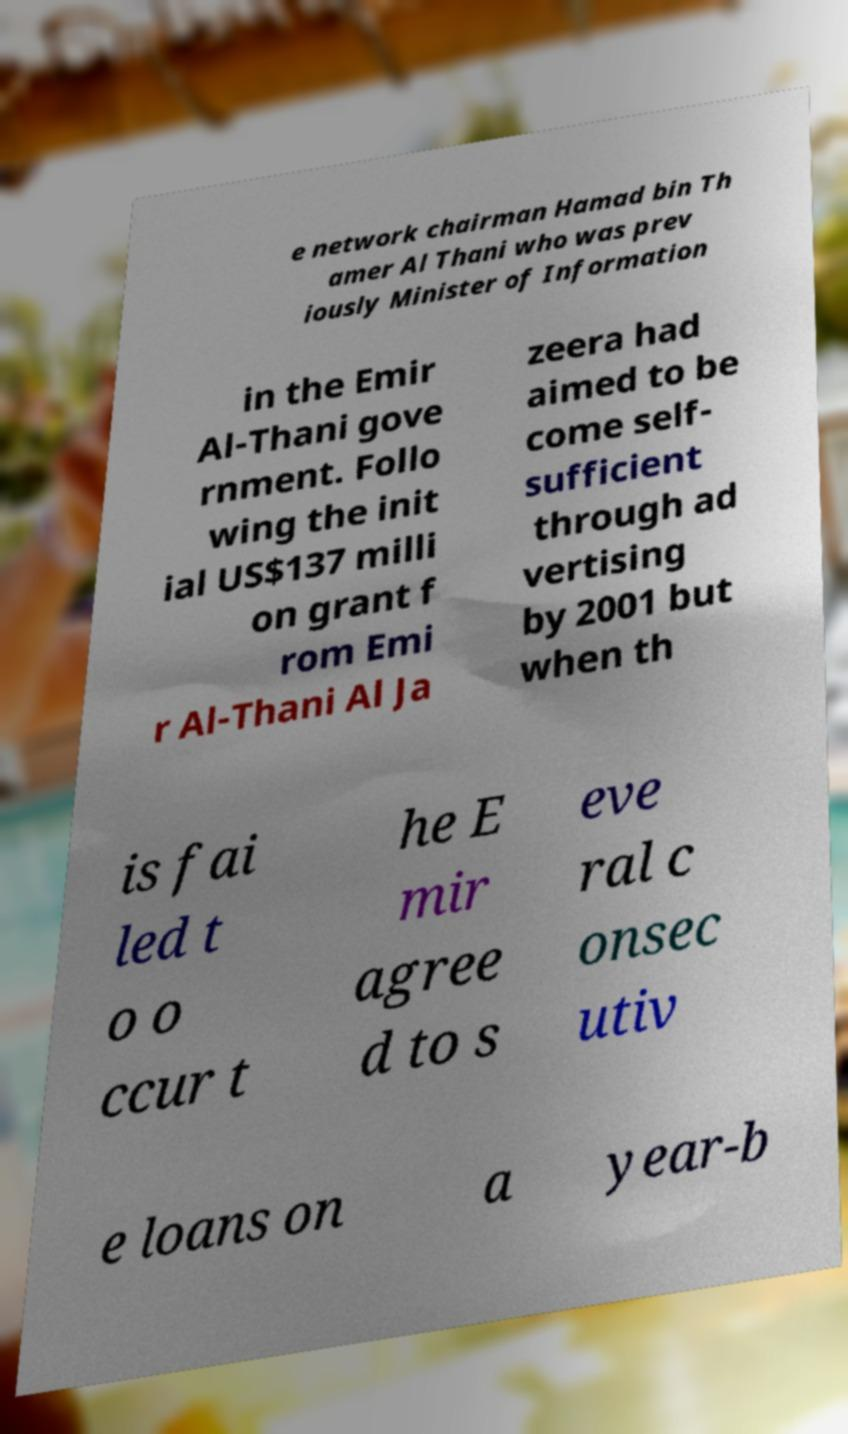There's text embedded in this image that I need extracted. Can you transcribe it verbatim? e network chairman Hamad bin Th amer Al Thani who was prev iously Minister of Information in the Emir Al-Thani gove rnment. Follo wing the init ial US$137 milli on grant f rom Emi r Al-Thani Al Ja zeera had aimed to be come self- sufficient through ad vertising by 2001 but when th is fai led t o o ccur t he E mir agree d to s eve ral c onsec utiv e loans on a year-b 